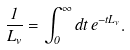<formula> <loc_0><loc_0><loc_500><loc_500>\frac { 1 } { L _ { v } } = \int _ { 0 } ^ { \infty } d t \, e ^ { - t L _ { v } } .</formula> 